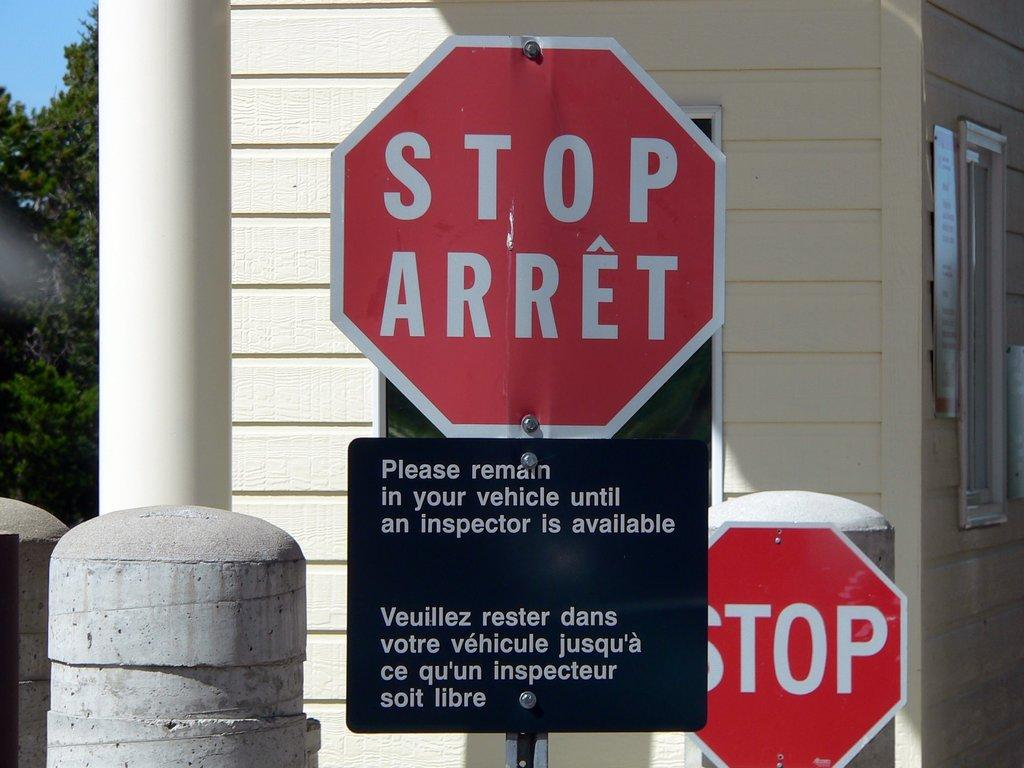<image>
Write a terse but informative summary of the picture. A pair of stop signs and a request to stay in vehicle below it. 